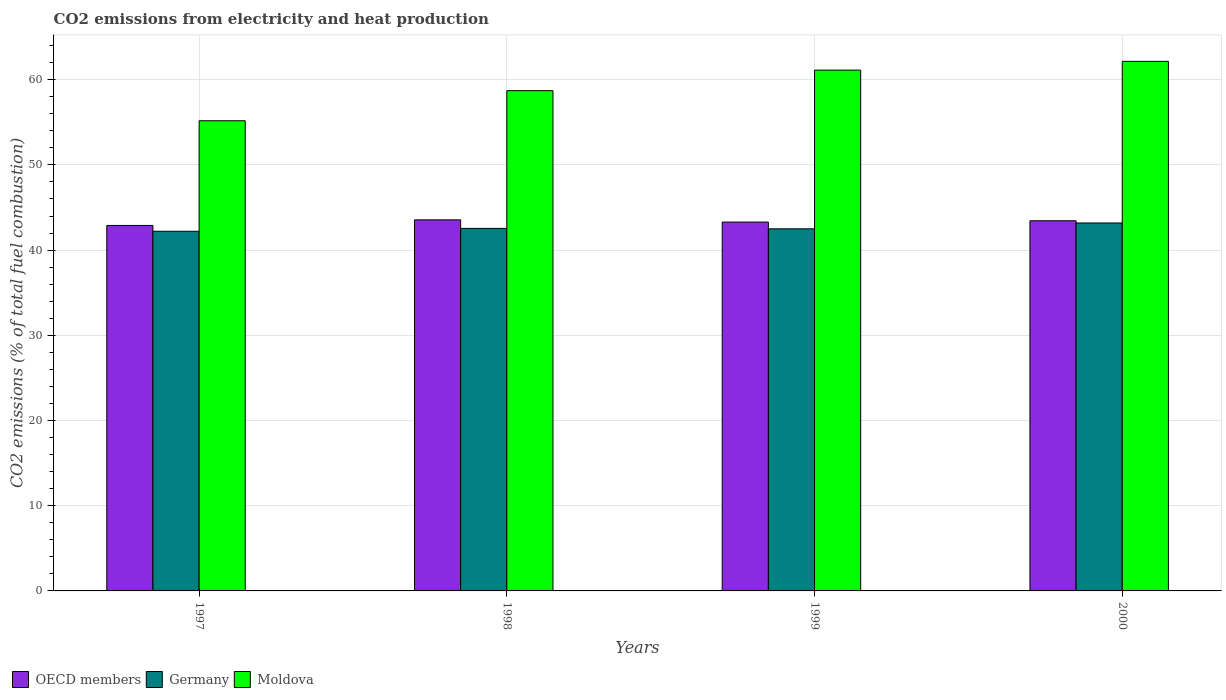How many groups of bars are there?
Provide a short and direct response. 4. Are the number of bars per tick equal to the number of legend labels?
Make the answer very short. Yes. Are the number of bars on each tick of the X-axis equal?
Give a very brief answer. Yes. How many bars are there on the 1st tick from the right?
Your response must be concise. 3. What is the amount of CO2 emitted in Germany in 1997?
Your answer should be compact. 42.21. Across all years, what is the maximum amount of CO2 emitted in OECD members?
Your response must be concise. 43.55. Across all years, what is the minimum amount of CO2 emitted in Moldova?
Offer a very short reply. 55.18. In which year was the amount of CO2 emitted in Moldova maximum?
Offer a very short reply. 2000. In which year was the amount of CO2 emitted in OECD members minimum?
Ensure brevity in your answer.  1997. What is the total amount of CO2 emitted in Germany in the graph?
Your answer should be compact. 170.45. What is the difference between the amount of CO2 emitted in Germany in 1997 and that in 1999?
Provide a succinct answer. -0.29. What is the difference between the amount of CO2 emitted in Moldova in 1998 and the amount of CO2 emitted in OECD members in 1997?
Make the answer very short. 15.82. What is the average amount of CO2 emitted in Germany per year?
Your answer should be very brief. 42.61. In the year 1997, what is the difference between the amount of CO2 emitted in Moldova and amount of CO2 emitted in Germany?
Offer a terse response. 12.97. In how many years, is the amount of CO2 emitted in Moldova greater than 8 %?
Offer a very short reply. 4. What is the ratio of the amount of CO2 emitted in Germany in 1997 to that in 2000?
Offer a very short reply. 0.98. Is the amount of CO2 emitted in Germany in 1997 less than that in 2000?
Offer a terse response. Yes. Is the difference between the amount of CO2 emitted in Moldova in 1998 and 2000 greater than the difference between the amount of CO2 emitted in Germany in 1998 and 2000?
Give a very brief answer. No. What is the difference between the highest and the second highest amount of CO2 emitted in OECD members?
Your answer should be very brief. 0.11. What is the difference between the highest and the lowest amount of CO2 emitted in Germany?
Your answer should be compact. 0.97. Is the sum of the amount of CO2 emitted in Moldova in 1998 and 2000 greater than the maximum amount of CO2 emitted in OECD members across all years?
Give a very brief answer. Yes. What does the 1st bar from the left in 1998 represents?
Provide a succinct answer. OECD members. What does the 1st bar from the right in 1997 represents?
Keep it short and to the point. Moldova. How many years are there in the graph?
Provide a short and direct response. 4. Does the graph contain any zero values?
Offer a terse response. No. Does the graph contain grids?
Provide a succinct answer. Yes. How many legend labels are there?
Provide a succinct answer. 3. What is the title of the graph?
Your answer should be very brief. CO2 emissions from electricity and heat production. Does "Isle of Man" appear as one of the legend labels in the graph?
Provide a short and direct response. No. What is the label or title of the Y-axis?
Offer a terse response. CO2 emissions (% of total fuel combustion). What is the CO2 emissions (% of total fuel combustion) in OECD members in 1997?
Make the answer very short. 42.89. What is the CO2 emissions (% of total fuel combustion) of Germany in 1997?
Your answer should be very brief. 42.21. What is the CO2 emissions (% of total fuel combustion) in Moldova in 1997?
Provide a short and direct response. 55.18. What is the CO2 emissions (% of total fuel combustion) of OECD members in 1998?
Provide a short and direct response. 43.55. What is the CO2 emissions (% of total fuel combustion) in Germany in 1998?
Your answer should be very brief. 42.55. What is the CO2 emissions (% of total fuel combustion) of Moldova in 1998?
Provide a succinct answer. 58.71. What is the CO2 emissions (% of total fuel combustion) of OECD members in 1999?
Make the answer very short. 43.29. What is the CO2 emissions (% of total fuel combustion) in Germany in 1999?
Ensure brevity in your answer.  42.5. What is the CO2 emissions (% of total fuel combustion) in Moldova in 1999?
Your response must be concise. 61.13. What is the CO2 emissions (% of total fuel combustion) in OECD members in 2000?
Your answer should be very brief. 43.44. What is the CO2 emissions (% of total fuel combustion) of Germany in 2000?
Your answer should be very brief. 43.18. What is the CO2 emissions (% of total fuel combustion) of Moldova in 2000?
Your answer should be compact. 62.15. Across all years, what is the maximum CO2 emissions (% of total fuel combustion) of OECD members?
Make the answer very short. 43.55. Across all years, what is the maximum CO2 emissions (% of total fuel combustion) in Germany?
Provide a short and direct response. 43.18. Across all years, what is the maximum CO2 emissions (% of total fuel combustion) in Moldova?
Give a very brief answer. 62.15. Across all years, what is the minimum CO2 emissions (% of total fuel combustion) in OECD members?
Make the answer very short. 42.89. Across all years, what is the minimum CO2 emissions (% of total fuel combustion) in Germany?
Keep it short and to the point. 42.21. Across all years, what is the minimum CO2 emissions (% of total fuel combustion) of Moldova?
Your answer should be very brief. 55.18. What is the total CO2 emissions (% of total fuel combustion) of OECD members in the graph?
Provide a short and direct response. 173.18. What is the total CO2 emissions (% of total fuel combustion) of Germany in the graph?
Your answer should be compact. 170.45. What is the total CO2 emissions (% of total fuel combustion) of Moldova in the graph?
Ensure brevity in your answer.  237.18. What is the difference between the CO2 emissions (% of total fuel combustion) in OECD members in 1997 and that in 1998?
Your answer should be very brief. -0.66. What is the difference between the CO2 emissions (% of total fuel combustion) in Germany in 1997 and that in 1998?
Provide a short and direct response. -0.34. What is the difference between the CO2 emissions (% of total fuel combustion) in Moldova in 1997 and that in 1998?
Make the answer very short. -3.53. What is the difference between the CO2 emissions (% of total fuel combustion) in OECD members in 1997 and that in 1999?
Make the answer very short. -0.4. What is the difference between the CO2 emissions (% of total fuel combustion) of Germany in 1997 and that in 1999?
Keep it short and to the point. -0.29. What is the difference between the CO2 emissions (% of total fuel combustion) in Moldova in 1997 and that in 1999?
Offer a terse response. -5.94. What is the difference between the CO2 emissions (% of total fuel combustion) of OECD members in 1997 and that in 2000?
Provide a succinct answer. -0.55. What is the difference between the CO2 emissions (% of total fuel combustion) in Germany in 1997 and that in 2000?
Offer a very short reply. -0.97. What is the difference between the CO2 emissions (% of total fuel combustion) in Moldova in 1997 and that in 2000?
Provide a succinct answer. -6.97. What is the difference between the CO2 emissions (% of total fuel combustion) in OECD members in 1998 and that in 1999?
Ensure brevity in your answer.  0.26. What is the difference between the CO2 emissions (% of total fuel combustion) in Germany in 1998 and that in 1999?
Make the answer very short. 0.05. What is the difference between the CO2 emissions (% of total fuel combustion) of Moldova in 1998 and that in 1999?
Offer a very short reply. -2.42. What is the difference between the CO2 emissions (% of total fuel combustion) of OECD members in 1998 and that in 2000?
Your answer should be compact. 0.11. What is the difference between the CO2 emissions (% of total fuel combustion) in Germany in 1998 and that in 2000?
Offer a terse response. -0.64. What is the difference between the CO2 emissions (% of total fuel combustion) of Moldova in 1998 and that in 2000?
Your response must be concise. -3.44. What is the difference between the CO2 emissions (% of total fuel combustion) of OECD members in 1999 and that in 2000?
Provide a short and direct response. -0.15. What is the difference between the CO2 emissions (% of total fuel combustion) in Germany in 1999 and that in 2000?
Provide a succinct answer. -0.69. What is the difference between the CO2 emissions (% of total fuel combustion) of Moldova in 1999 and that in 2000?
Give a very brief answer. -1.03. What is the difference between the CO2 emissions (% of total fuel combustion) of OECD members in 1997 and the CO2 emissions (% of total fuel combustion) of Germany in 1998?
Your answer should be compact. 0.34. What is the difference between the CO2 emissions (% of total fuel combustion) in OECD members in 1997 and the CO2 emissions (% of total fuel combustion) in Moldova in 1998?
Your answer should be very brief. -15.82. What is the difference between the CO2 emissions (% of total fuel combustion) in Germany in 1997 and the CO2 emissions (% of total fuel combustion) in Moldova in 1998?
Provide a short and direct response. -16.5. What is the difference between the CO2 emissions (% of total fuel combustion) of OECD members in 1997 and the CO2 emissions (% of total fuel combustion) of Germany in 1999?
Give a very brief answer. 0.4. What is the difference between the CO2 emissions (% of total fuel combustion) in OECD members in 1997 and the CO2 emissions (% of total fuel combustion) in Moldova in 1999?
Keep it short and to the point. -18.23. What is the difference between the CO2 emissions (% of total fuel combustion) of Germany in 1997 and the CO2 emissions (% of total fuel combustion) of Moldova in 1999?
Give a very brief answer. -18.91. What is the difference between the CO2 emissions (% of total fuel combustion) in OECD members in 1997 and the CO2 emissions (% of total fuel combustion) in Germany in 2000?
Give a very brief answer. -0.29. What is the difference between the CO2 emissions (% of total fuel combustion) of OECD members in 1997 and the CO2 emissions (% of total fuel combustion) of Moldova in 2000?
Offer a very short reply. -19.26. What is the difference between the CO2 emissions (% of total fuel combustion) of Germany in 1997 and the CO2 emissions (% of total fuel combustion) of Moldova in 2000?
Give a very brief answer. -19.94. What is the difference between the CO2 emissions (% of total fuel combustion) in OECD members in 1998 and the CO2 emissions (% of total fuel combustion) in Germany in 1999?
Your answer should be compact. 1.05. What is the difference between the CO2 emissions (% of total fuel combustion) of OECD members in 1998 and the CO2 emissions (% of total fuel combustion) of Moldova in 1999?
Give a very brief answer. -17.58. What is the difference between the CO2 emissions (% of total fuel combustion) in Germany in 1998 and the CO2 emissions (% of total fuel combustion) in Moldova in 1999?
Your answer should be compact. -18.58. What is the difference between the CO2 emissions (% of total fuel combustion) in OECD members in 1998 and the CO2 emissions (% of total fuel combustion) in Germany in 2000?
Keep it short and to the point. 0.37. What is the difference between the CO2 emissions (% of total fuel combustion) of OECD members in 1998 and the CO2 emissions (% of total fuel combustion) of Moldova in 2000?
Keep it short and to the point. -18.6. What is the difference between the CO2 emissions (% of total fuel combustion) of Germany in 1998 and the CO2 emissions (% of total fuel combustion) of Moldova in 2000?
Keep it short and to the point. -19.6. What is the difference between the CO2 emissions (% of total fuel combustion) in OECD members in 1999 and the CO2 emissions (% of total fuel combustion) in Germany in 2000?
Your answer should be compact. 0.11. What is the difference between the CO2 emissions (% of total fuel combustion) in OECD members in 1999 and the CO2 emissions (% of total fuel combustion) in Moldova in 2000?
Offer a terse response. -18.86. What is the difference between the CO2 emissions (% of total fuel combustion) in Germany in 1999 and the CO2 emissions (% of total fuel combustion) in Moldova in 2000?
Provide a short and direct response. -19.66. What is the average CO2 emissions (% of total fuel combustion) of OECD members per year?
Provide a short and direct response. 43.29. What is the average CO2 emissions (% of total fuel combustion) in Germany per year?
Provide a succinct answer. 42.61. What is the average CO2 emissions (% of total fuel combustion) of Moldova per year?
Offer a very short reply. 59.29. In the year 1997, what is the difference between the CO2 emissions (% of total fuel combustion) of OECD members and CO2 emissions (% of total fuel combustion) of Germany?
Provide a short and direct response. 0.68. In the year 1997, what is the difference between the CO2 emissions (% of total fuel combustion) in OECD members and CO2 emissions (% of total fuel combustion) in Moldova?
Your answer should be very brief. -12.29. In the year 1997, what is the difference between the CO2 emissions (% of total fuel combustion) of Germany and CO2 emissions (% of total fuel combustion) of Moldova?
Provide a short and direct response. -12.97. In the year 1998, what is the difference between the CO2 emissions (% of total fuel combustion) in OECD members and CO2 emissions (% of total fuel combustion) in Germany?
Ensure brevity in your answer.  1. In the year 1998, what is the difference between the CO2 emissions (% of total fuel combustion) of OECD members and CO2 emissions (% of total fuel combustion) of Moldova?
Ensure brevity in your answer.  -15.16. In the year 1998, what is the difference between the CO2 emissions (% of total fuel combustion) in Germany and CO2 emissions (% of total fuel combustion) in Moldova?
Keep it short and to the point. -16.16. In the year 1999, what is the difference between the CO2 emissions (% of total fuel combustion) in OECD members and CO2 emissions (% of total fuel combustion) in Germany?
Offer a very short reply. 0.79. In the year 1999, what is the difference between the CO2 emissions (% of total fuel combustion) in OECD members and CO2 emissions (% of total fuel combustion) in Moldova?
Your answer should be very brief. -17.84. In the year 1999, what is the difference between the CO2 emissions (% of total fuel combustion) of Germany and CO2 emissions (% of total fuel combustion) of Moldova?
Offer a very short reply. -18.63. In the year 2000, what is the difference between the CO2 emissions (% of total fuel combustion) in OECD members and CO2 emissions (% of total fuel combustion) in Germany?
Provide a succinct answer. 0.26. In the year 2000, what is the difference between the CO2 emissions (% of total fuel combustion) of OECD members and CO2 emissions (% of total fuel combustion) of Moldova?
Your answer should be compact. -18.71. In the year 2000, what is the difference between the CO2 emissions (% of total fuel combustion) of Germany and CO2 emissions (% of total fuel combustion) of Moldova?
Provide a short and direct response. -18.97. What is the ratio of the CO2 emissions (% of total fuel combustion) in OECD members in 1997 to that in 1998?
Your response must be concise. 0.98. What is the ratio of the CO2 emissions (% of total fuel combustion) in Germany in 1997 to that in 1998?
Offer a very short reply. 0.99. What is the ratio of the CO2 emissions (% of total fuel combustion) of Moldova in 1997 to that in 1998?
Your answer should be compact. 0.94. What is the ratio of the CO2 emissions (% of total fuel combustion) in OECD members in 1997 to that in 1999?
Your answer should be compact. 0.99. What is the ratio of the CO2 emissions (% of total fuel combustion) in Germany in 1997 to that in 1999?
Your response must be concise. 0.99. What is the ratio of the CO2 emissions (% of total fuel combustion) of Moldova in 1997 to that in 1999?
Keep it short and to the point. 0.9. What is the ratio of the CO2 emissions (% of total fuel combustion) in OECD members in 1997 to that in 2000?
Provide a succinct answer. 0.99. What is the ratio of the CO2 emissions (% of total fuel combustion) of Germany in 1997 to that in 2000?
Give a very brief answer. 0.98. What is the ratio of the CO2 emissions (% of total fuel combustion) in Moldova in 1997 to that in 2000?
Offer a very short reply. 0.89. What is the ratio of the CO2 emissions (% of total fuel combustion) of OECD members in 1998 to that in 1999?
Give a very brief answer. 1.01. What is the ratio of the CO2 emissions (% of total fuel combustion) in Germany in 1998 to that in 1999?
Your response must be concise. 1. What is the ratio of the CO2 emissions (% of total fuel combustion) in Moldova in 1998 to that in 1999?
Give a very brief answer. 0.96. What is the ratio of the CO2 emissions (% of total fuel combustion) in OECD members in 1998 to that in 2000?
Provide a succinct answer. 1. What is the ratio of the CO2 emissions (% of total fuel combustion) in Germany in 1998 to that in 2000?
Your answer should be very brief. 0.99. What is the ratio of the CO2 emissions (% of total fuel combustion) in Moldova in 1998 to that in 2000?
Your answer should be compact. 0.94. What is the ratio of the CO2 emissions (% of total fuel combustion) in OECD members in 1999 to that in 2000?
Provide a short and direct response. 1. What is the ratio of the CO2 emissions (% of total fuel combustion) in Germany in 1999 to that in 2000?
Give a very brief answer. 0.98. What is the ratio of the CO2 emissions (% of total fuel combustion) in Moldova in 1999 to that in 2000?
Your response must be concise. 0.98. What is the difference between the highest and the second highest CO2 emissions (% of total fuel combustion) in OECD members?
Keep it short and to the point. 0.11. What is the difference between the highest and the second highest CO2 emissions (% of total fuel combustion) in Germany?
Ensure brevity in your answer.  0.64. What is the difference between the highest and the second highest CO2 emissions (% of total fuel combustion) of Moldova?
Make the answer very short. 1.03. What is the difference between the highest and the lowest CO2 emissions (% of total fuel combustion) of OECD members?
Make the answer very short. 0.66. What is the difference between the highest and the lowest CO2 emissions (% of total fuel combustion) of Germany?
Ensure brevity in your answer.  0.97. What is the difference between the highest and the lowest CO2 emissions (% of total fuel combustion) of Moldova?
Make the answer very short. 6.97. 